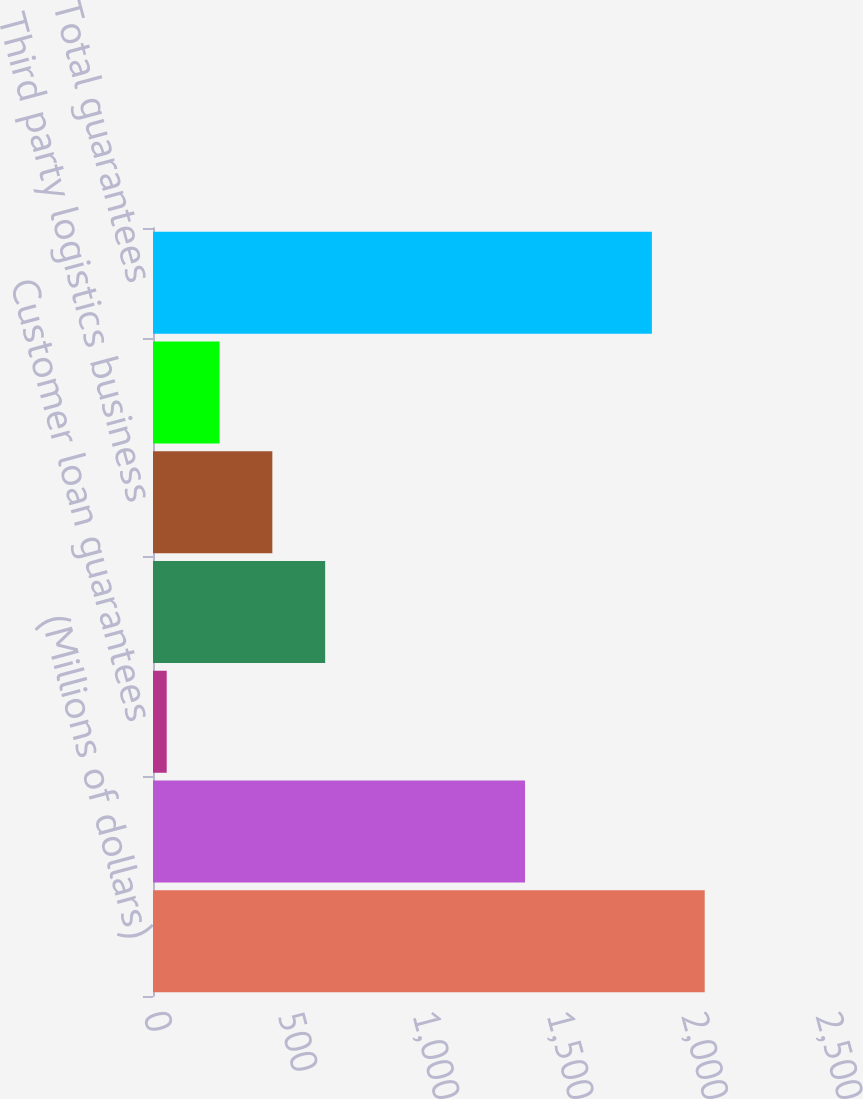Convert chart to OTSL. <chart><loc_0><loc_0><loc_500><loc_500><bar_chart><fcel>(Millions of dollars)<fcel>Caterpillar dealer performance<fcel>Customer loan guarantees<fcel>Supplier consortium<fcel>Third party logistics business<fcel>Other guarantees<fcel>Total guarantees<nl><fcel>2052.5<fcel>1384<fcel>51<fcel>640.5<fcel>444<fcel>247.5<fcel>1856<nl></chart> 